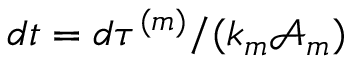Convert formula to latex. <formula><loc_0><loc_0><loc_500><loc_500>d t = d \tau ^ { ( m ) } / ( k _ { m } \mathcal { A } _ { m } )</formula> 